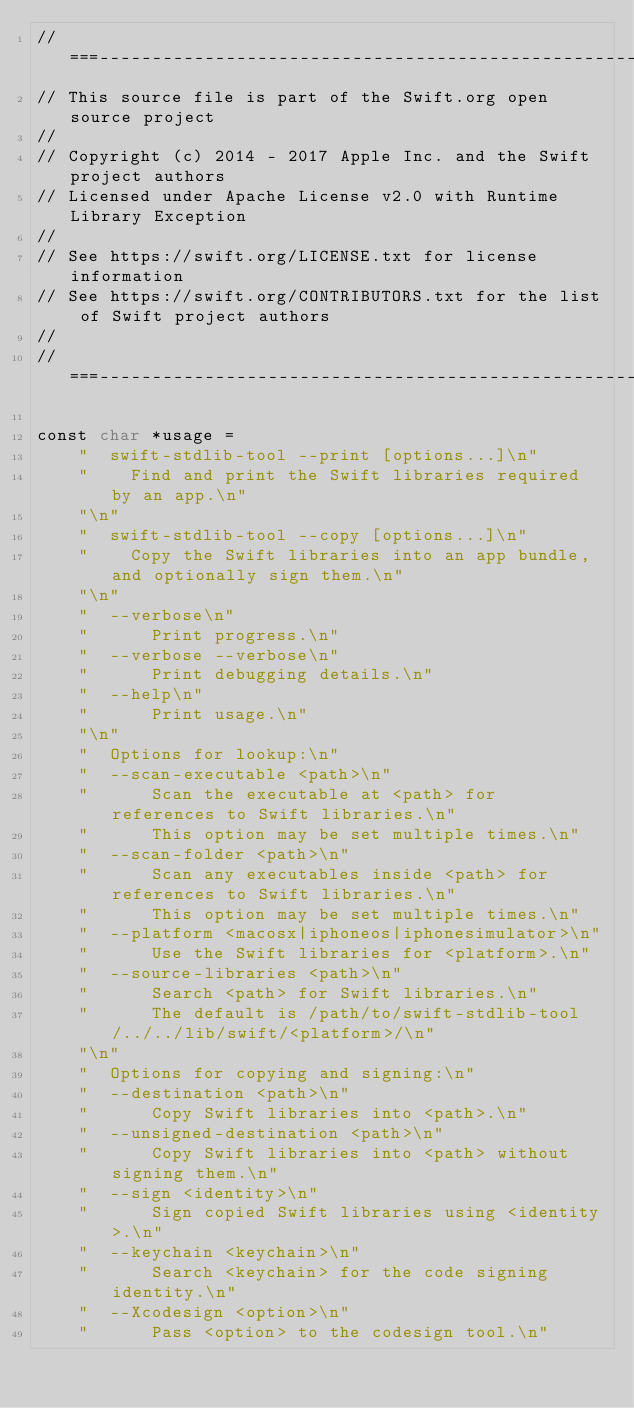Convert code to text. <code><loc_0><loc_0><loc_500><loc_500><_ObjectiveC_>//===----------------------------------------------------------------------===//
// This source file is part of the Swift.org open source project
//
// Copyright (c) 2014 - 2017 Apple Inc. and the Swift project authors
// Licensed under Apache License v2.0 with Runtime Library Exception
//
// See https://swift.org/LICENSE.txt for license information
// See https://swift.org/CONTRIBUTORS.txt for the list of Swift project authors
//
//===----------------------------------------------------------------------===//

const char *usage = 
    "  swift-stdlib-tool --print [options...]\n"
    "    Find and print the Swift libraries required by an app.\n"
    "\n"
    "  swift-stdlib-tool --copy [options...]\n"
    "    Copy the Swift libraries into an app bundle, and optionally sign them.\n"
    "\n"
    "  --verbose\n"
    "      Print progress.\n"
    "  --verbose --verbose\n"
    "      Print debugging details.\n"
    "  --help\n"
    "      Print usage.\n"
    "\n"
    "  Options for lookup:\n"
    "  --scan-executable <path>\n"
    "      Scan the executable at <path> for references to Swift libraries.\n"
    "      This option may be set multiple times.\n"
    "  --scan-folder <path>\n"
    "      Scan any executables inside <path> for references to Swift libraries.\n"
    "      This option may be set multiple times.\n"
    "  --platform <macosx|iphoneos|iphonesimulator>\n"
    "      Use the Swift libraries for <platform>.\n"
    "  --source-libraries <path>\n"
    "      Search <path> for Swift libraries.\n"
    "      The default is /path/to/swift-stdlib-tool/../../lib/swift/<platform>/\n"
    "\n"
    "  Options for copying and signing:\n"
    "  --destination <path>\n"
    "      Copy Swift libraries into <path>.\n"
    "  --unsigned-destination <path>\n"
    "      Copy Swift libraries into <path> without signing them.\n"
    "  --sign <identity>\n"
    "      Sign copied Swift libraries using <identity>.\n"
    "  --keychain <keychain>\n"
    "      Search <keychain> for the code signing identity.\n"
    "  --Xcodesign <option>\n"
    "      Pass <option> to the codesign tool.\n"</code> 